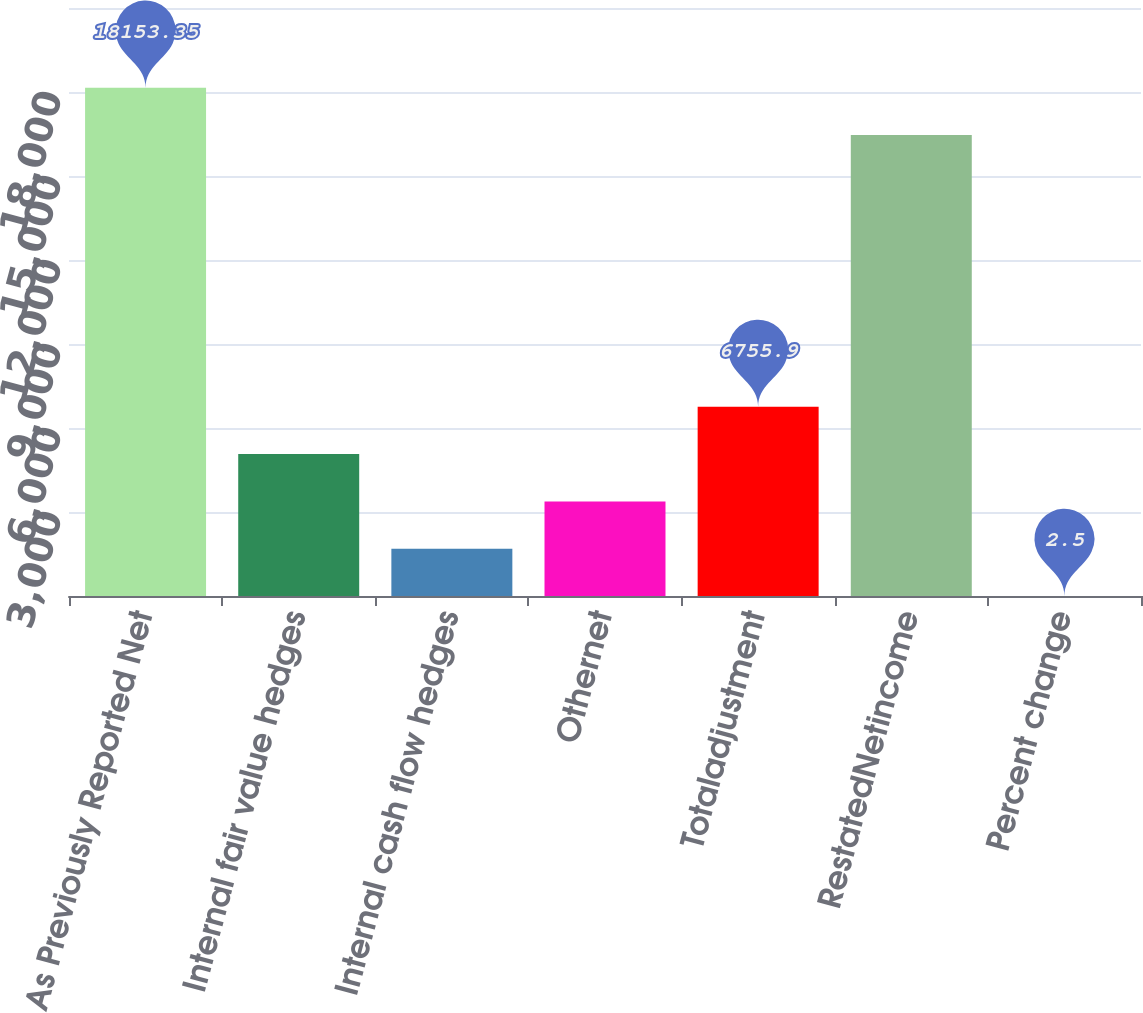<chart> <loc_0><loc_0><loc_500><loc_500><bar_chart><fcel>As Previously Reported Net<fcel>Internal fair value hedges<fcel>Internal cash flow hedges<fcel>Othernet<fcel>Totaladjustment<fcel>RestatedNetincome<fcel>Percent change<nl><fcel>18153.3<fcel>5067.55<fcel>1690.85<fcel>3379.2<fcel>6755.9<fcel>16465<fcel>2.5<nl></chart> 